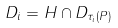Convert formula to latex. <formula><loc_0><loc_0><loc_500><loc_500>D _ { i } = H \cap D _ { \tau _ { i } ( P ) }</formula> 